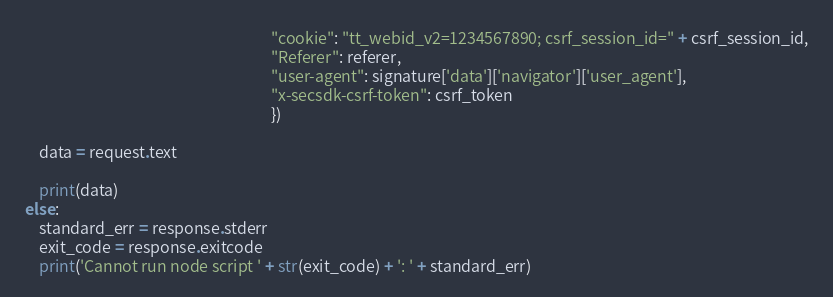Convert code to text. <code><loc_0><loc_0><loc_500><loc_500><_Python_>                                                                     "cookie": "tt_webid_v2=1234567890; csrf_session_id=" + csrf_session_id,
                                                                     "Referer": referer,
                                                                     "user-agent": signature['data']['navigator']['user_agent'],
                                                                     "x-secsdk-csrf-token": csrf_token
                                                                     })

    data = request.text

    print(data)
else:
    standard_err = response.stderr
    exit_code = response.exitcode
    print('Cannot run node script ' + str(exit_code) + ': ' + standard_err)
</code> 